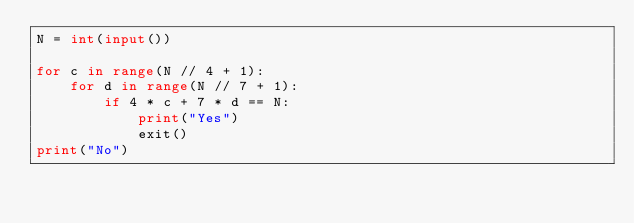Convert code to text. <code><loc_0><loc_0><loc_500><loc_500><_Python_>N = int(input())

for c in range(N // 4 + 1):
    for d in range(N // 7 + 1):
        if 4 * c + 7 * d == N:
            print("Yes")
            exit()
print("No")</code> 